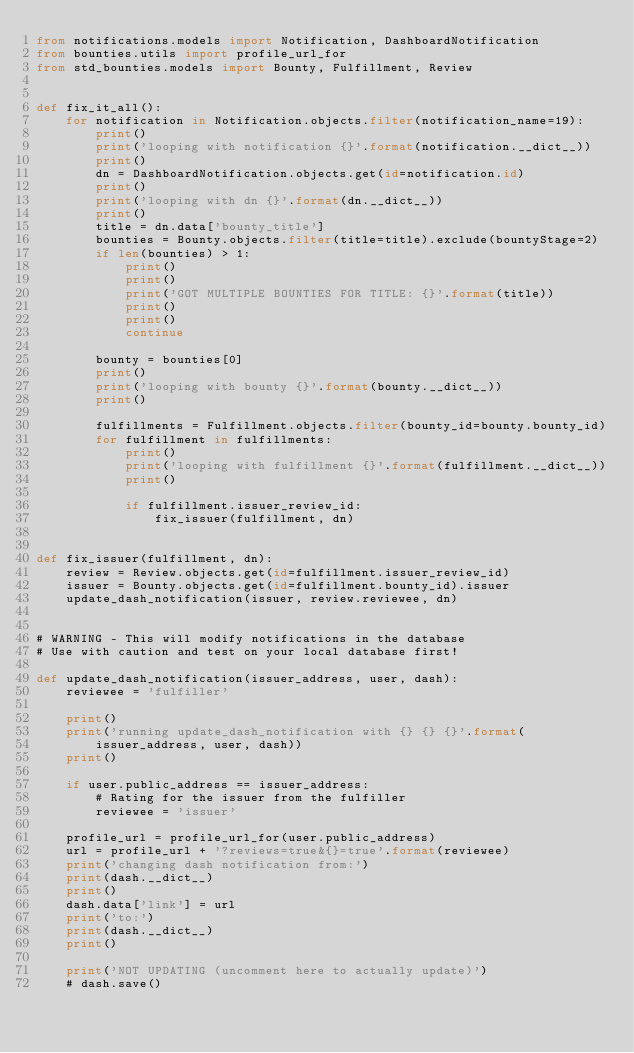<code> <loc_0><loc_0><loc_500><loc_500><_Python_>from notifications.models import Notification, DashboardNotification
from bounties.utils import profile_url_for
from std_bounties.models import Bounty, Fulfillment, Review


def fix_it_all():
    for notification in Notification.objects.filter(notification_name=19):
        print()
        print('looping with notification {}'.format(notification.__dict__))
        print()
        dn = DashboardNotification.objects.get(id=notification.id)
        print()
        print('looping with dn {}'.format(dn.__dict__))
        print()
        title = dn.data['bounty_title']
        bounties = Bounty.objects.filter(title=title).exclude(bountyStage=2)
        if len(bounties) > 1:
            print()
            print()
            print('GOT MULTIPLE BOUNTIES FOR TITLE: {}'.format(title))
            print()
            print()
            continue

        bounty = bounties[0]
        print()
        print('looping with bounty {}'.format(bounty.__dict__))
        print()

        fulfillments = Fulfillment.objects.filter(bounty_id=bounty.bounty_id)
        for fulfillment in fulfillments:
            print()
            print('looping with fulfillment {}'.format(fulfillment.__dict__))
            print()

            if fulfillment.issuer_review_id:
                fix_issuer(fulfillment, dn)


def fix_issuer(fulfillment, dn):
    review = Review.objects.get(id=fulfillment.issuer_review_id)
    issuer = Bounty.objects.get(id=fulfillment.bounty_id).issuer
    update_dash_notification(issuer, review.reviewee, dn)


# WARNING - This will modify notifications in the database
# Use with caution and test on your local database first!

def update_dash_notification(issuer_address, user, dash):
    reviewee = 'fulfiller'

    print()
    print('running update_dash_notification with {} {} {}'.format(
        issuer_address, user, dash))
    print()

    if user.public_address == issuer_address:
        # Rating for the issuer from the fulfiller
        reviewee = 'issuer'

    profile_url = profile_url_for(user.public_address)
    url = profile_url + '?reviews=true&{}=true'.format(reviewee)
    print('changing dash notification from:')
    print(dash.__dict__)
    print()
    dash.data['link'] = url
    print('to:')
    print(dash.__dict__)
    print()

    print('NOT UPDATING (uncomment here to actually update)')
    # dash.save()
</code> 